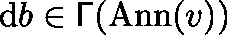<formula> <loc_0><loc_0><loc_500><loc_500>d b \in \Gamma ( A n n ( v ) )</formula> 